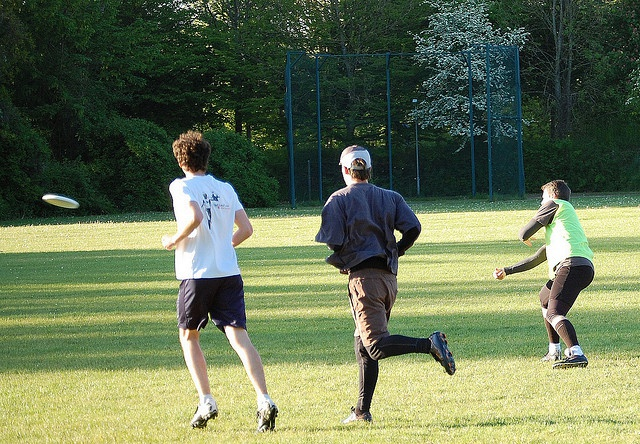Describe the objects in this image and their specific colors. I can see people in black, white, lightblue, and darkgray tones, people in black, navy, gray, and ivory tones, people in black, ivory, lightgreen, and khaki tones, and frisbee in black, olive, white, lightblue, and gray tones in this image. 